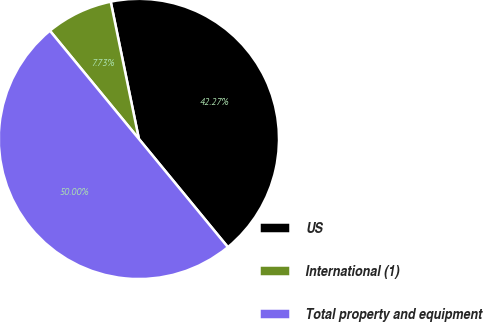Convert chart. <chart><loc_0><loc_0><loc_500><loc_500><pie_chart><fcel>US<fcel>International (1)<fcel>Total property and equipment<nl><fcel>42.27%<fcel>7.73%<fcel>50.0%<nl></chart> 